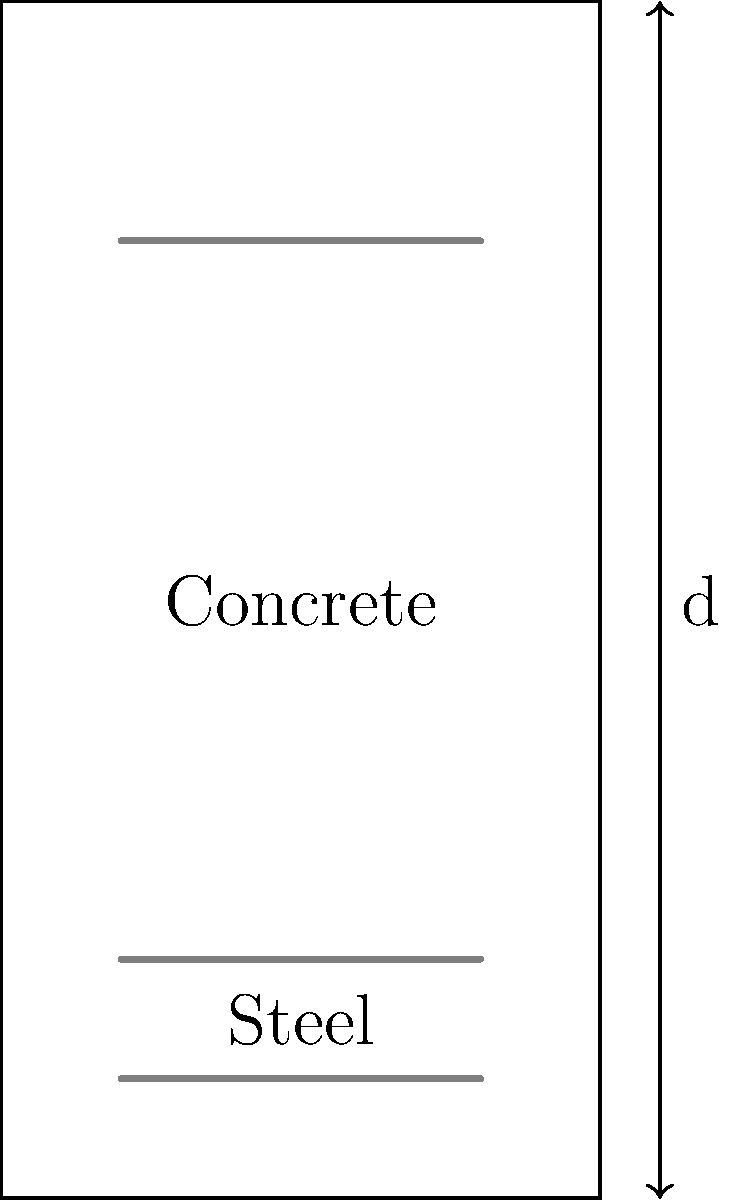In the realm of structural poetry, where concrete and steel dance in harmony, observe the cross-section of a reinforced concrete beam. If the effective depth (d) is 18 cm and the overall depth is 20 cm, what is the cover provided to the tension reinforcement? Express your answer as a verse in centimeters, reflecting on the protection offered to the steel within. To find the cover provided to the tension reinforcement, we'll follow these poetic steps:

1. Visualize the beam's composition:
   The overall depth is the full height of our concrete canvas (20 cm).
   The effective depth (d) is the distance from the compression face to the centroid of tension reinforcement (18 cm).

2. Contemplate the difference:
   The cover is the space between the beam's edge and the reinforcement.
   It's the difference between the overall depth and the effective depth.

3. Perform the calculation:
   Cover = Overall depth - Effective depth
   $$\text{Cover} = 20 \text{ cm} - 18 \text{ cm} = 2 \text{ cm}$$

4. Reflect on the meaning:
   This 2 cm layer is like a protective mantra, shielding the steel from the outside world,
   Allowing it to perform its tensile dance within the concrete's embrace.

Thus, the cover provided to the tension reinforcement is 2 cm, a thin but crucial layer in the beam's structural poetry.
Answer: 2 cm 